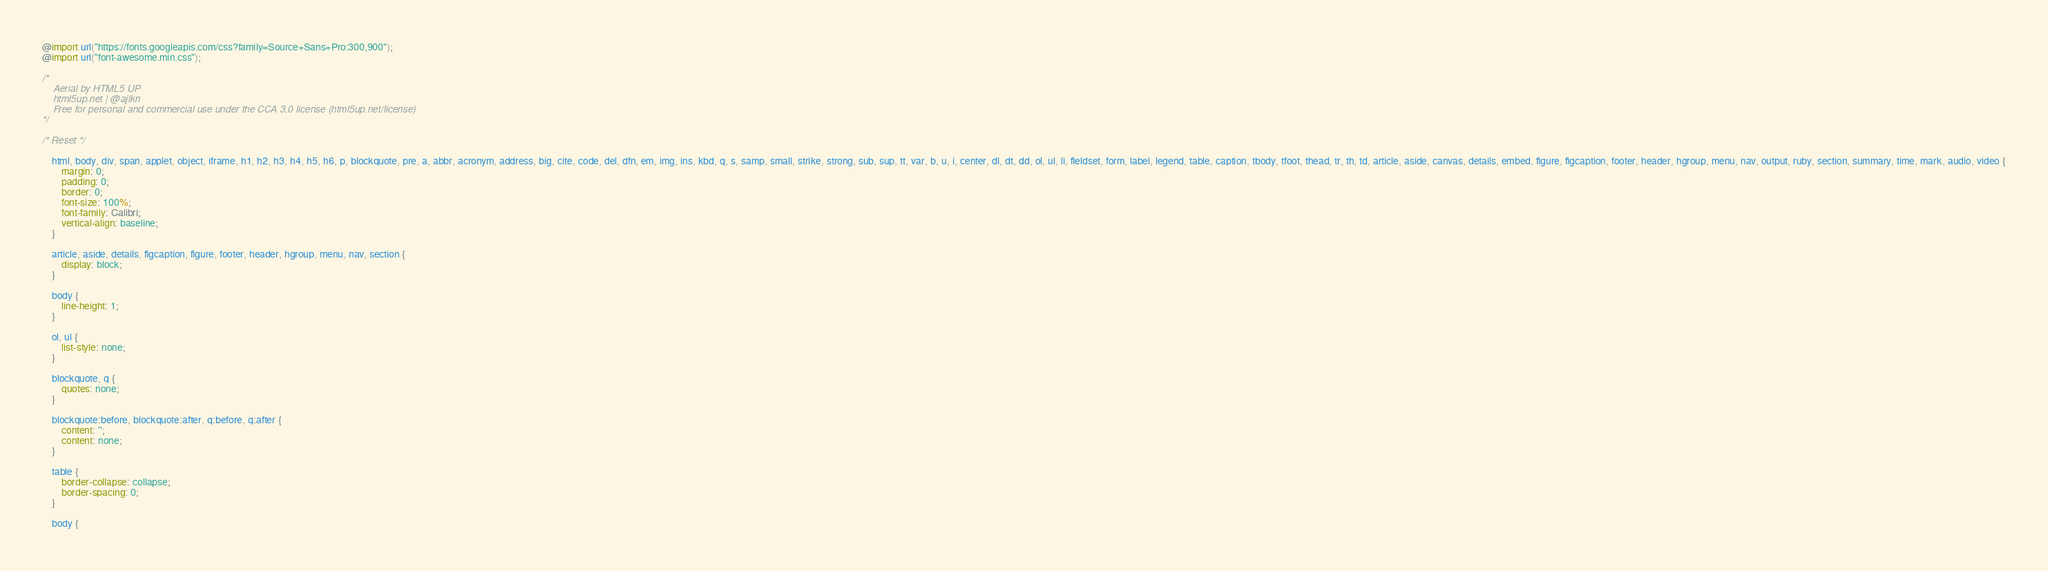Convert code to text. <code><loc_0><loc_0><loc_500><loc_500><_CSS_>@import url("https://fonts.googleapis.com/css?family=Source+Sans+Pro:300,900");
@import url("font-awesome.min.css");

/*
	Aerial by HTML5 UP
	html5up.net | @ajlkn
	Free for personal and commercial use under the CCA 3.0 license (html5up.net/license)
*/

/* Reset */

	html, body, div, span, applet, object, iframe, h1, h2, h3, h4, h5, h6, p, blockquote, pre, a, abbr, acronym, address, big, cite, code, del, dfn, em, img, ins, kbd, q, s, samp, small, strike, strong, sub, sup, tt, var, b, u, i, center, dl, dt, dd, ol, ul, li, fieldset, form, label, legend, table, caption, tbody, tfoot, thead, tr, th, td, article, aside, canvas, details, embed, figure, figcaption, footer, header, hgroup, menu, nav, output, ruby, section, summary, time, mark, audio, video {
		margin: 0;
		padding: 0;
		border: 0;
		font-size: 100%;
		font-family: Calibri;
		vertical-align: baseline;
	}

	article, aside, details, figcaption, figure, footer, header, hgroup, menu, nav, section {
		display: block;
	}

	body {
		line-height: 1;
	}

	ol, ul {
		list-style: none;
	}

	blockquote, q {
		quotes: none;
	}

	blockquote:before, blockquote:after, q:before, q:after {
		content: '';
		content: none;
	}

	table {
		border-collapse: collapse;
		border-spacing: 0;
	}

	body {</code> 